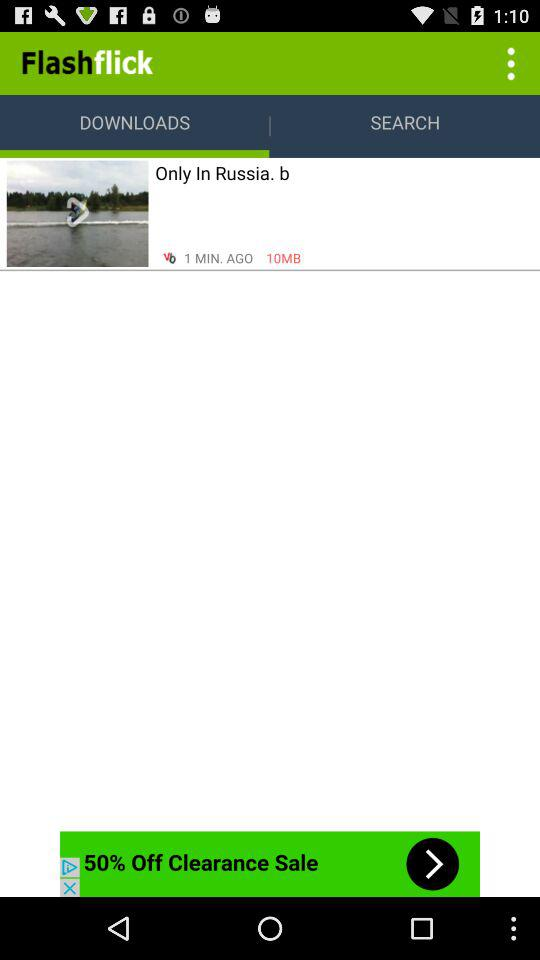What is the selected option? The selected option is "DOWNLOADS". 